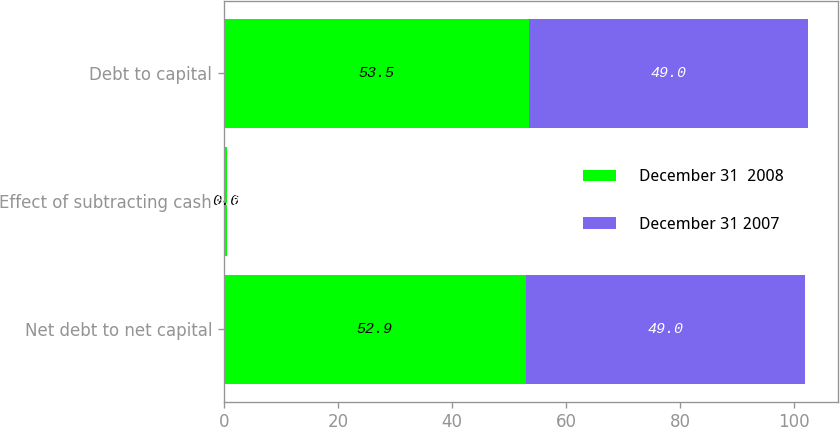Convert chart. <chart><loc_0><loc_0><loc_500><loc_500><stacked_bar_chart><ecel><fcel>Net debt to net capital<fcel>Effect of subtracting cash<fcel>Debt to capital<nl><fcel>December 31  2008<fcel>52.9<fcel>0.6<fcel>53.5<nl><fcel>December 31 2007<fcel>49<fcel>0<fcel>49<nl></chart> 